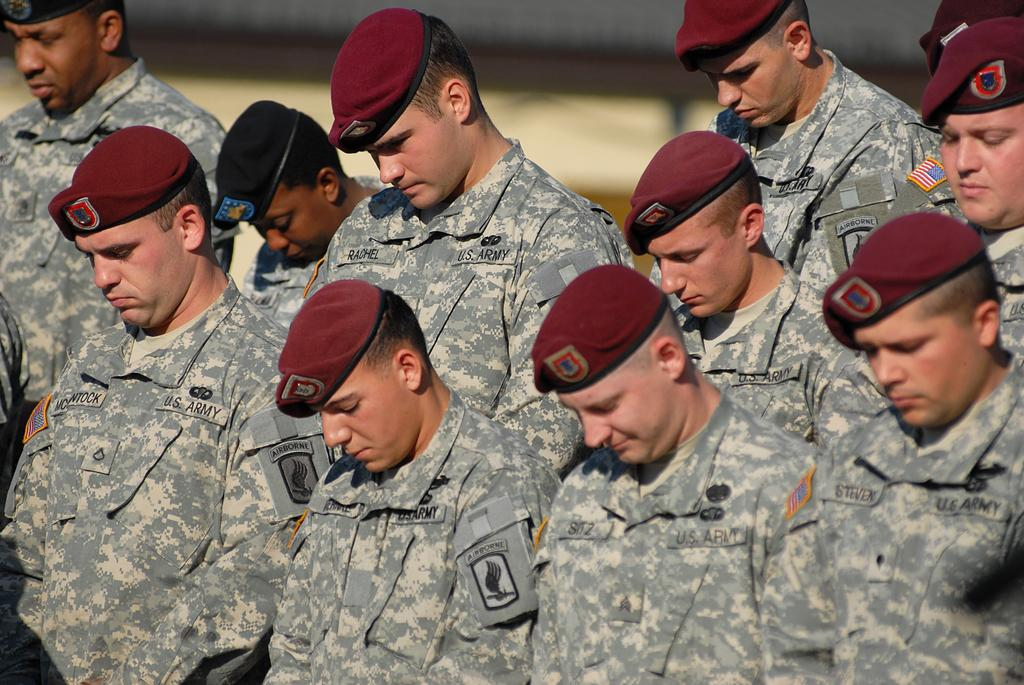What is the main subject of the image? The main subject of the image is a group of people. What are the people wearing in the image? The people are wearing caps in the image. What are the people doing in the image? The people are standing in the image. Can you describe the background of the image? The background of the image is blurry. Reasoning: Let' Let's think step by step in order to produce the conversation. We start by identifying the main subject of the image, which is the group of people. Then, we describe what the people are wearing and doing, which are known from the provided facts. Finally, we address the background of the image, noting that it is blurry. Absurd Question/Answer: What type of pizzas are being served on the table in the image? There is no table or pizzas present in the image; it features a group of people wearing caps and standing. How many jars of jam can be seen on the shelf in the image? There is no shelf or jam present in the image; it features a group of people wearing caps and standing. How many light bulbs are hanging from the ceiling in the image? There are no light bulbs or ceiling present in the image; it features a group of people wearing caps and standing. 